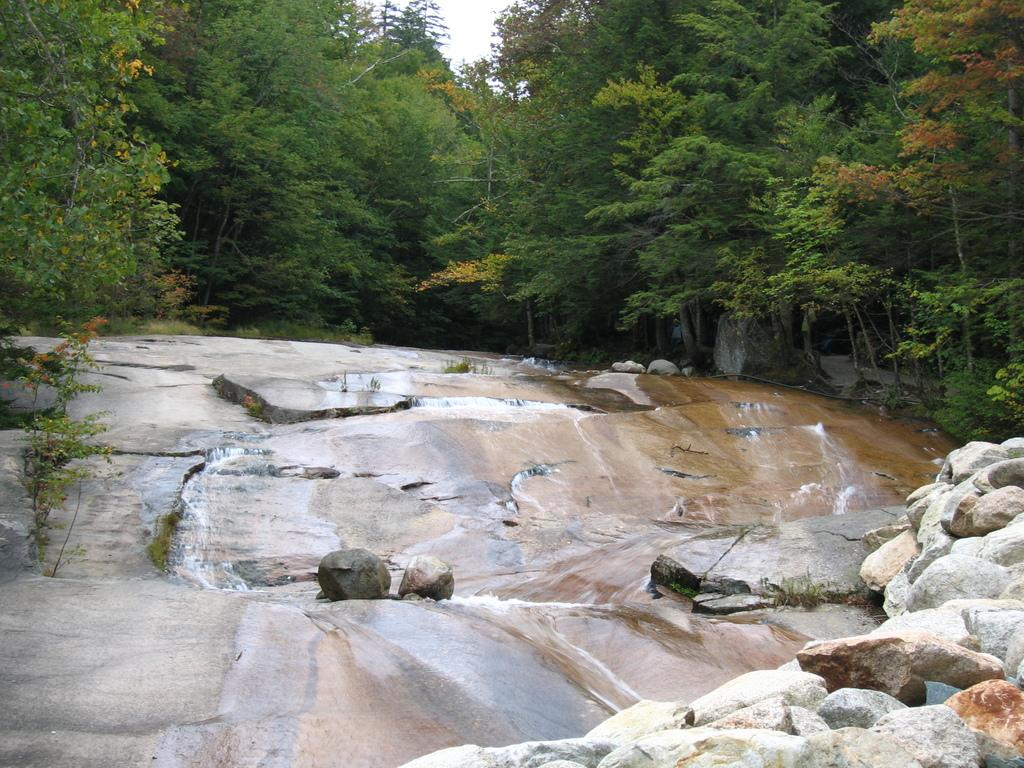What type of natural elements are present in the image? The image contains rocks, water, trees, and plants. Can you describe the movement of water in the image? There is water flowing in the foreground of the image. Where are the trees located in the image? The trees are at the top of the image. What can be seen on the left side of the image? There are plants on the left side of the image. What type of bell can be heard ringing in the image? There is no bell present in the image, and therefore no sound can be heard. 